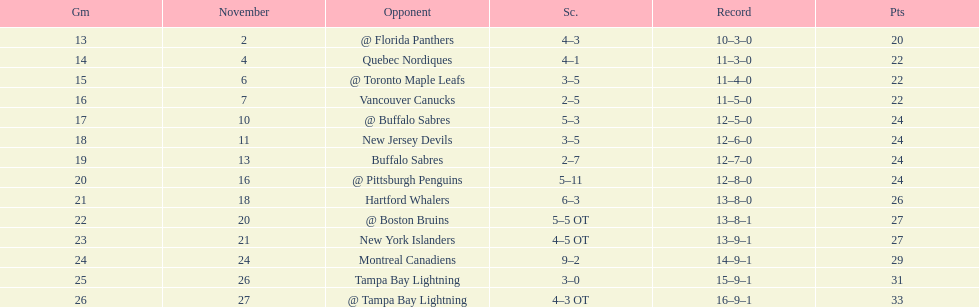What other team had the closest amount of wins? New York Islanders. 